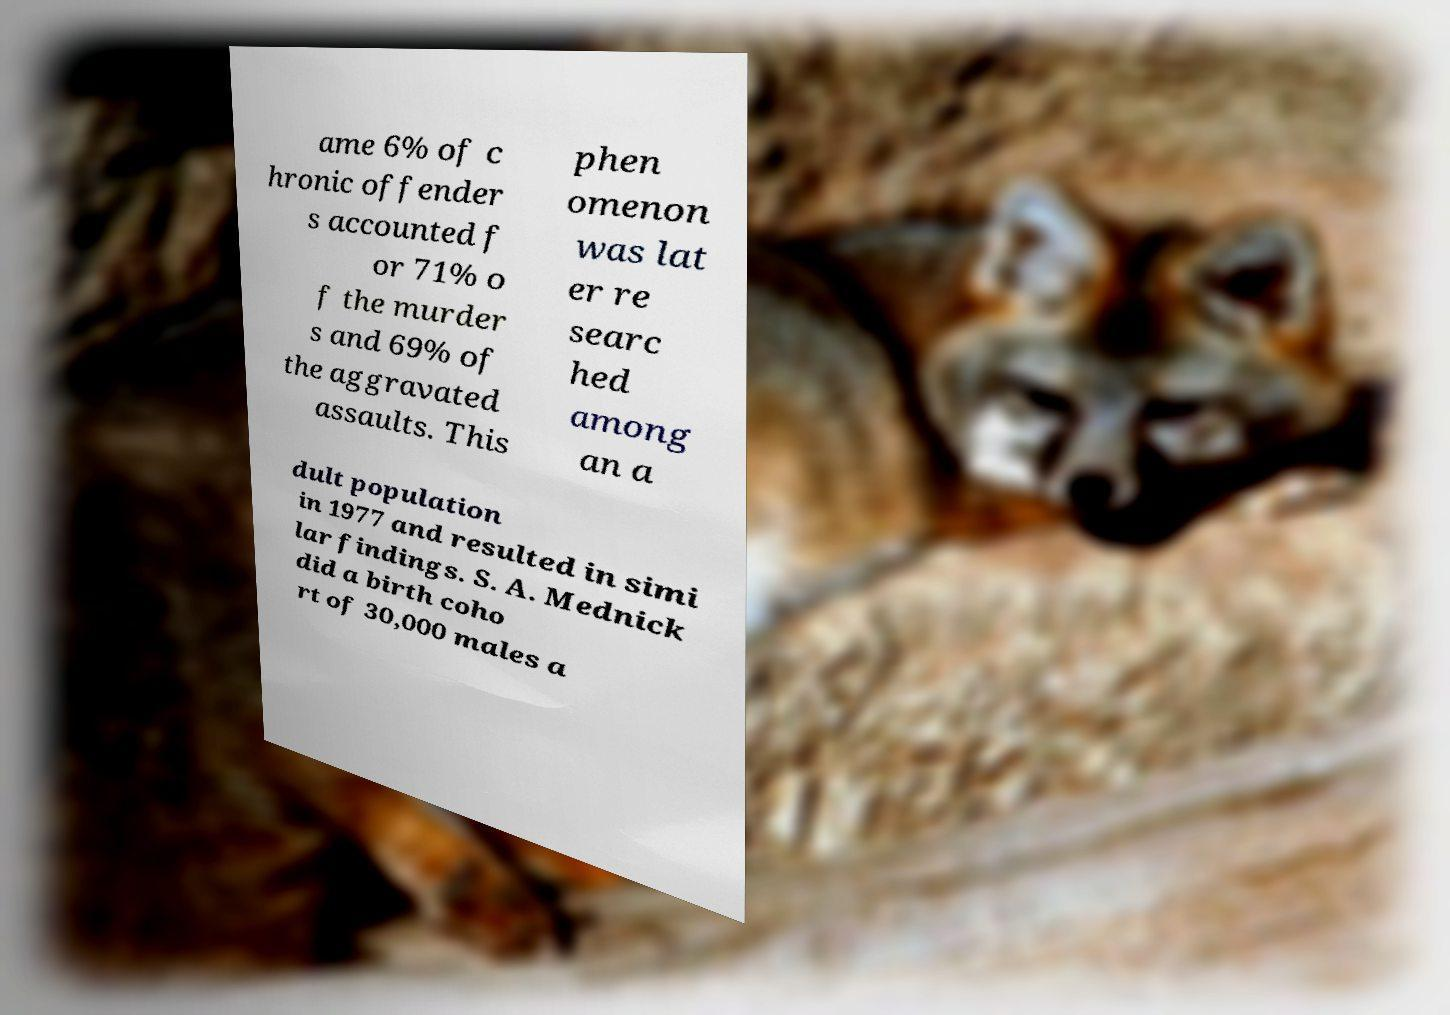Could you extract and type out the text from this image? ame 6% of c hronic offender s accounted f or 71% o f the murder s and 69% of the aggravated assaults. This phen omenon was lat er re searc hed among an a dult population in 1977 and resulted in simi lar findings. S. A. Mednick did a birth coho rt of 30,000 males a 